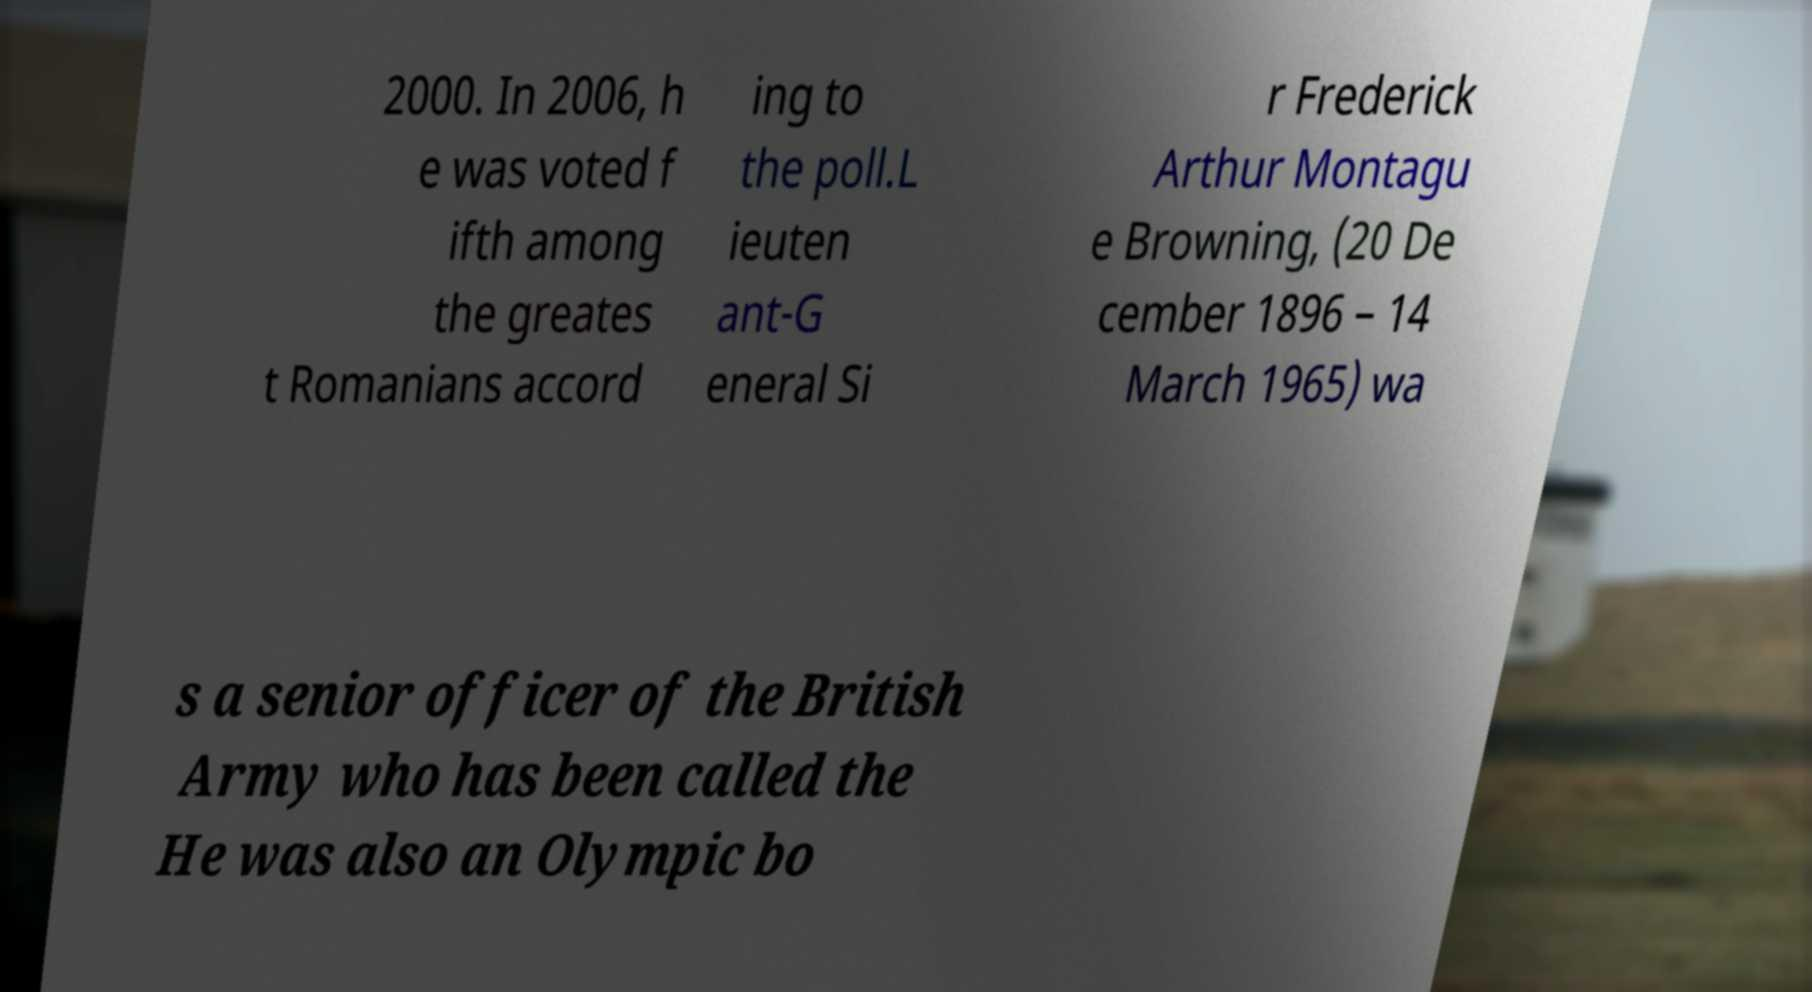Could you extract and type out the text from this image? 2000. In 2006, h e was voted f ifth among the greates t Romanians accord ing to the poll.L ieuten ant-G eneral Si r Frederick Arthur Montagu e Browning, (20 De cember 1896 – 14 March 1965) wa s a senior officer of the British Army who has been called the He was also an Olympic bo 